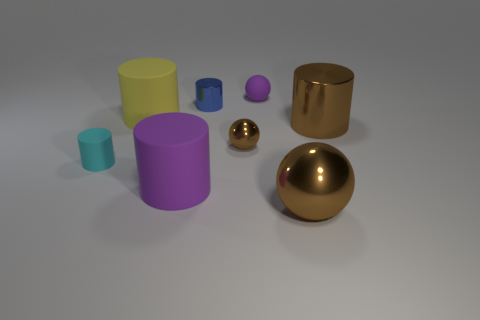There is a brown thing that is the same size as the blue shiny object; what shape is it?
Your answer should be very brief. Sphere. Are there any other matte things that have the same shape as the cyan object?
Give a very brief answer. Yes. There is a large object that is right of the big shiny sphere; is its color the same as the big rubber object that is behind the tiny cyan object?
Offer a terse response. No. Are there any brown metallic objects on the right side of the purple sphere?
Offer a very short reply. Yes. There is a cylinder that is both in front of the small brown ball and to the right of the big yellow cylinder; what material is it?
Offer a very short reply. Rubber. Is the purple object right of the big purple rubber object made of the same material as the large purple cylinder?
Provide a short and direct response. Yes. What is the material of the small purple sphere?
Your answer should be compact. Rubber. There is a rubber cylinder to the right of the yellow object; what is its size?
Offer a terse response. Large. Is there anything else of the same color as the big shiny cylinder?
Make the answer very short. Yes. There is a metallic sphere in front of the tiny metal thing that is in front of the blue cylinder; is there a small cyan object to the right of it?
Give a very brief answer. No. 